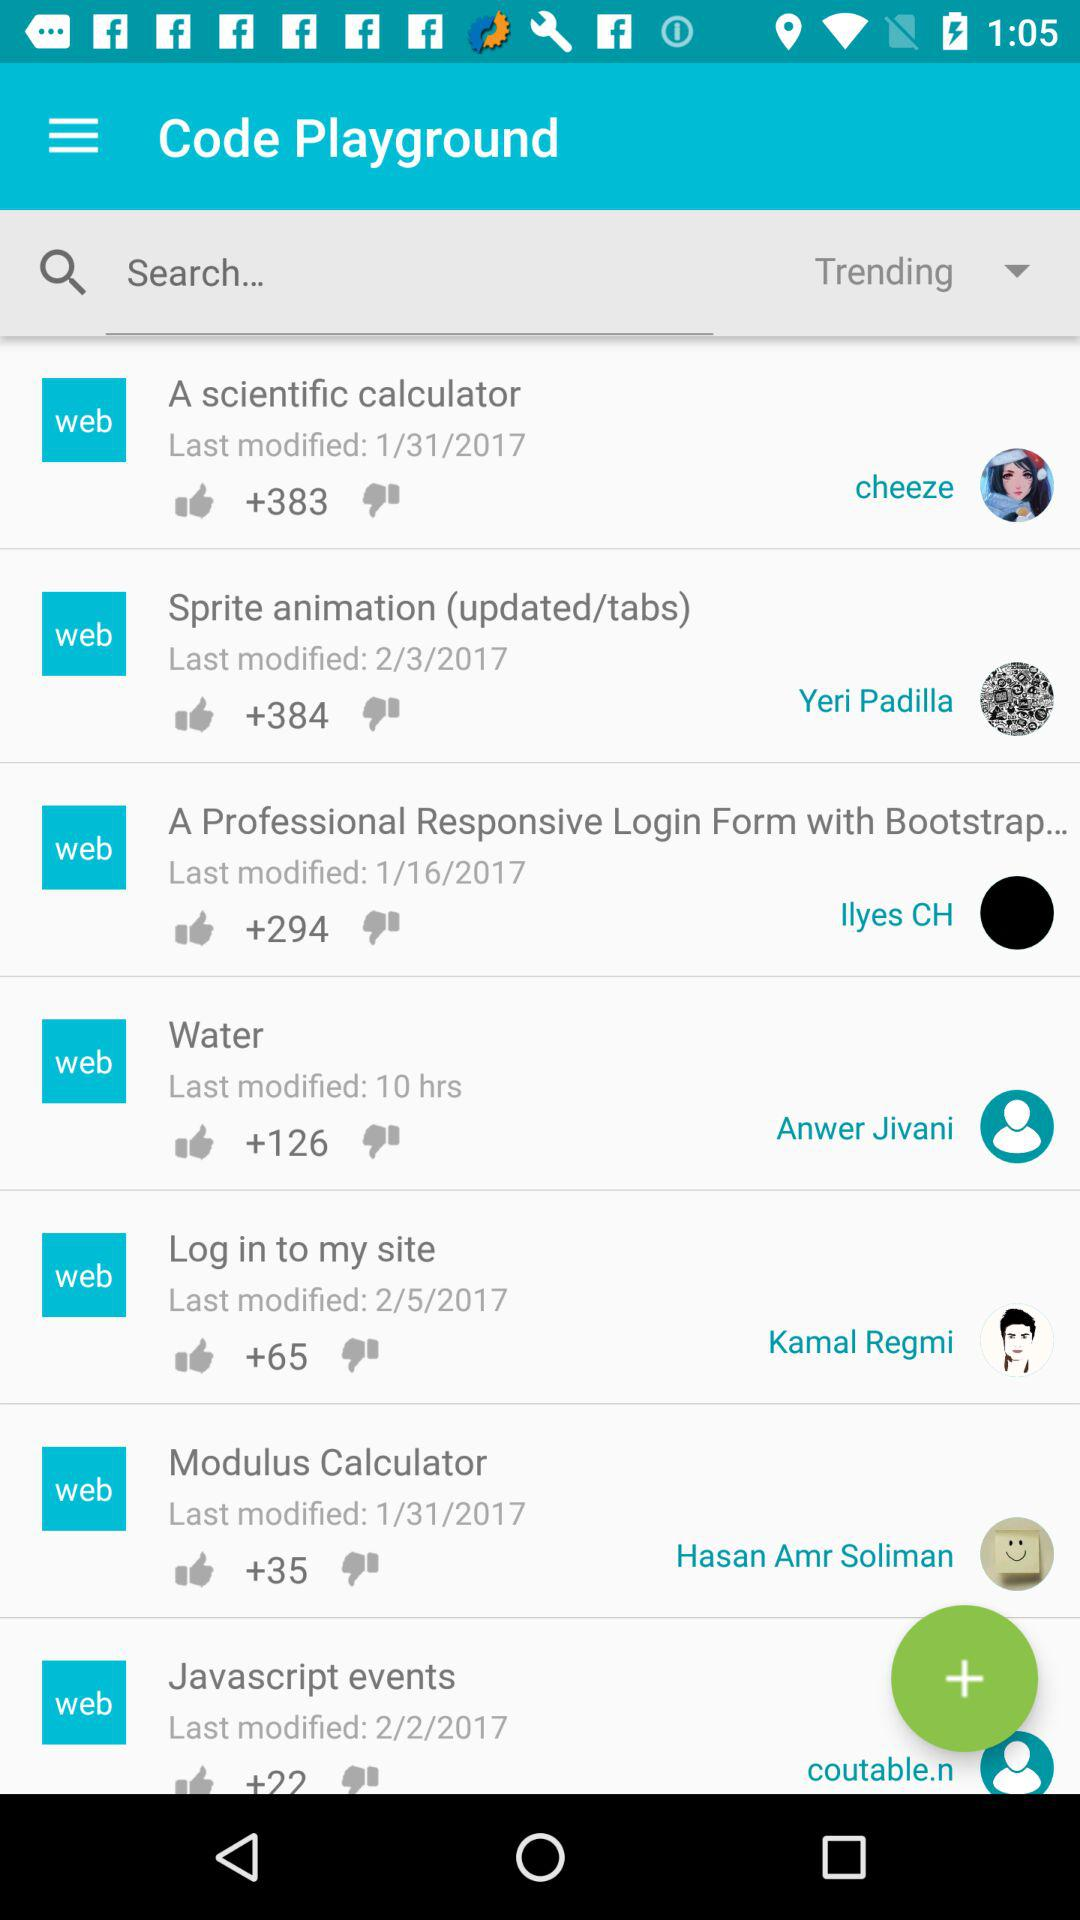Which option is selected? The selected option is "Trending". 